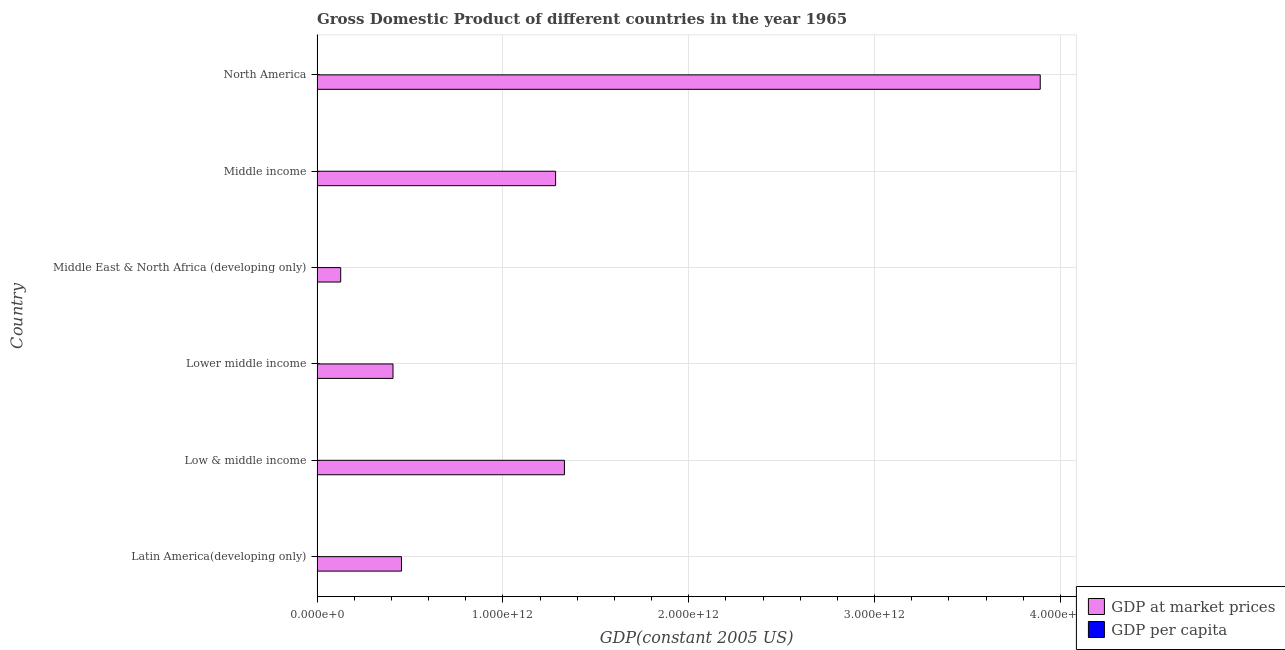How many groups of bars are there?
Provide a short and direct response. 6. Are the number of bars per tick equal to the number of legend labels?
Ensure brevity in your answer.  Yes. How many bars are there on the 4th tick from the bottom?
Ensure brevity in your answer.  2. What is the label of the 2nd group of bars from the top?
Make the answer very short. Middle income. In how many cases, is the number of bars for a given country not equal to the number of legend labels?
Keep it short and to the point. 0. What is the gdp per capita in Latin America(developing only)?
Ensure brevity in your answer.  2209.64. Across all countries, what is the maximum gdp at market prices?
Ensure brevity in your answer.  3.89e+12. Across all countries, what is the minimum gdp per capita?
Provide a short and direct response. 386.81. In which country was the gdp at market prices minimum?
Provide a short and direct response. Middle East & North Africa (developing only). What is the total gdp per capita in the graph?
Provide a succinct answer. 2.31e+04. What is the difference between the gdp at market prices in Low & middle income and that in Lower middle income?
Provide a short and direct response. 9.22e+11. What is the difference between the gdp at market prices in Middle income and the gdp per capita in Middle East & North Africa (developing only)?
Provide a short and direct response. 1.28e+12. What is the average gdp per capita per country?
Ensure brevity in your answer.  3844.58. What is the difference between the gdp per capita and gdp at market prices in Low & middle income?
Ensure brevity in your answer.  -1.33e+12. What is the ratio of the gdp at market prices in Lower middle income to that in Middle East & North Africa (developing only)?
Make the answer very short. 3.21. What is the difference between the highest and the second highest gdp at market prices?
Offer a very short reply. 2.56e+12. What is the difference between the highest and the lowest gdp per capita?
Make the answer very short. 1.78e+04. In how many countries, is the gdp per capita greater than the average gdp per capita taken over all countries?
Give a very brief answer. 1. What does the 2nd bar from the top in Latin America(developing only) represents?
Offer a terse response. GDP at market prices. What does the 2nd bar from the bottom in Lower middle income represents?
Your answer should be very brief. GDP per capita. How many bars are there?
Offer a terse response. 12. How many countries are there in the graph?
Your response must be concise. 6. What is the difference between two consecutive major ticks on the X-axis?
Ensure brevity in your answer.  1.00e+12. Does the graph contain any zero values?
Offer a terse response. No. Does the graph contain grids?
Provide a succinct answer. Yes. Where does the legend appear in the graph?
Your answer should be very brief. Bottom right. What is the title of the graph?
Your response must be concise. Gross Domestic Product of different countries in the year 1965. What is the label or title of the X-axis?
Your answer should be compact. GDP(constant 2005 US). What is the GDP(constant 2005 US) of GDP at market prices in Latin America(developing only)?
Provide a short and direct response. 4.54e+11. What is the GDP(constant 2005 US) in GDP per capita in Latin America(developing only)?
Keep it short and to the point. 2209.64. What is the GDP(constant 2005 US) in GDP at market prices in Low & middle income?
Offer a very short reply. 1.33e+12. What is the GDP(constant 2005 US) of GDP per capita in Low & middle income?
Give a very brief answer. 564.57. What is the GDP(constant 2005 US) in GDP at market prices in Lower middle income?
Your answer should be very brief. 4.09e+11. What is the GDP(constant 2005 US) in GDP per capita in Lower middle income?
Provide a succinct answer. 386.81. What is the GDP(constant 2005 US) of GDP at market prices in Middle East & North Africa (developing only)?
Your response must be concise. 1.27e+11. What is the GDP(constant 2005 US) in GDP per capita in Middle East & North Africa (developing only)?
Ensure brevity in your answer.  1138.46. What is the GDP(constant 2005 US) of GDP at market prices in Middle income?
Provide a succinct answer. 1.28e+12. What is the GDP(constant 2005 US) of GDP per capita in Middle income?
Give a very brief answer. 588.27. What is the GDP(constant 2005 US) of GDP at market prices in North America?
Your answer should be compact. 3.89e+12. What is the GDP(constant 2005 US) in GDP per capita in North America?
Provide a succinct answer. 1.82e+04. Across all countries, what is the maximum GDP(constant 2005 US) of GDP at market prices?
Offer a terse response. 3.89e+12. Across all countries, what is the maximum GDP(constant 2005 US) in GDP per capita?
Make the answer very short. 1.82e+04. Across all countries, what is the minimum GDP(constant 2005 US) in GDP at market prices?
Your response must be concise. 1.27e+11. Across all countries, what is the minimum GDP(constant 2005 US) in GDP per capita?
Offer a terse response. 386.81. What is the total GDP(constant 2005 US) of GDP at market prices in the graph?
Offer a very short reply. 7.50e+12. What is the total GDP(constant 2005 US) of GDP per capita in the graph?
Provide a succinct answer. 2.31e+04. What is the difference between the GDP(constant 2005 US) of GDP at market prices in Latin America(developing only) and that in Low & middle income?
Your answer should be very brief. -8.77e+11. What is the difference between the GDP(constant 2005 US) of GDP per capita in Latin America(developing only) and that in Low & middle income?
Your answer should be very brief. 1645.07. What is the difference between the GDP(constant 2005 US) of GDP at market prices in Latin America(developing only) and that in Lower middle income?
Your answer should be very brief. 4.55e+1. What is the difference between the GDP(constant 2005 US) in GDP per capita in Latin America(developing only) and that in Lower middle income?
Provide a short and direct response. 1822.83. What is the difference between the GDP(constant 2005 US) in GDP at market prices in Latin America(developing only) and that in Middle East & North Africa (developing only)?
Keep it short and to the point. 3.27e+11. What is the difference between the GDP(constant 2005 US) in GDP per capita in Latin America(developing only) and that in Middle East & North Africa (developing only)?
Offer a terse response. 1071.17. What is the difference between the GDP(constant 2005 US) of GDP at market prices in Latin America(developing only) and that in Middle income?
Make the answer very short. -8.29e+11. What is the difference between the GDP(constant 2005 US) in GDP per capita in Latin America(developing only) and that in Middle income?
Your answer should be compact. 1621.37. What is the difference between the GDP(constant 2005 US) of GDP at market prices in Latin America(developing only) and that in North America?
Make the answer very short. -3.44e+12. What is the difference between the GDP(constant 2005 US) of GDP per capita in Latin America(developing only) and that in North America?
Make the answer very short. -1.60e+04. What is the difference between the GDP(constant 2005 US) in GDP at market prices in Low & middle income and that in Lower middle income?
Ensure brevity in your answer.  9.22e+11. What is the difference between the GDP(constant 2005 US) of GDP per capita in Low & middle income and that in Lower middle income?
Your answer should be very brief. 177.76. What is the difference between the GDP(constant 2005 US) of GDP at market prices in Low & middle income and that in Middle East & North Africa (developing only)?
Provide a succinct answer. 1.20e+12. What is the difference between the GDP(constant 2005 US) of GDP per capita in Low & middle income and that in Middle East & North Africa (developing only)?
Offer a very short reply. -573.89. What is the difference between the GDP(constant 2005 US) in GDP at market prices in Low & middle income and that in Middle income?
Give a very brief answer. 4.75e+1. What is the difference between the GDP(constant 2005 US) in GDP per capita in Low & middle income and that in Middle income?
Give a very brief answer. -23.69. What is the difference between the GDP(constant 2005 US) in GDP at market prices in Low & middle income and that in North America?
Offer a very short reply. -2.56e+12. What is the difference between the GDP(constant 2005 US) of GDP per capita in Low & middle income and that in North America?
Provide a succinct answer. -1.76e+04. What is the difference between the GDP(constant 2005 US) in GDP at market prices in Lower middle income and that in Middle East & North Africa (developing only)?
Ensure brevity in your answer.  2.81e+11. What is the difference between the GDP(constant 2005 US) of GDP per capita in Lower middle income and that in Middle East & North Africa (developing only)?
Your response must be concise. -751.65. What is the difference between the GDP(constant 2005 US) in GDP at market prices in Lower middle income and that in Middle income?
Offer a terse response. -8.75e+11. What is the difference between the GDP(constant 2005 US) of GDP per capita in Lower middle income and that in Middle income?
Offer a terse response. -201.46. What is the difference between the GDP(constant 2005 US) of GDP at market prices in Lower middle income and that in North America?
Your response must be concise. -3.48e+12. What is the difference between the GDP(constant 2005 US) of GDP per capita in Lower middle income and that in North America?
Offer a very short reply. -1.78e+04. What is the difference between the GDP(constant 2005 US) in GDP at market prices in Middle East & North Africa (developing only) and that in Middle income?
Provide a short and direct response. -1.16e+12. What is the difference between the GDP(constant 2005 US) of GDP per capita in Middle East & North Africa (developing only) and that in Middle income?
Offer a terse response. 550.2. What is the difference between the GDP(constant 2005 US) in GDP at market prices in Middle East & North Africa (developing only) and that in North America?
Your answer should be very brief. -3.76e+12. What is the difference between the GDP(constant 2005 US) in GDP per capita in Middle East & North Africa (developing only) and that in North America?
Give a very brief answer. -1.70e+04. What is the difference between the GDP(constant 2005 US) in GDP at market prices in Middle income and that in North America?
Your answer should be compact. -2.61e+12. What is the difference between the GDP(constant 2005 US) of GDP per capita in Middle income and that in North America?
Provide a short and direct response. -1.76e+04. What is the difference between the GDP(constant 2005 US) in GDP at market prices in Latin America(developing only) and the GDP(constant 2005 US) in GDP per capita in Low & middle income?
Give a very brief answer. 4.54e+11. What is the difference between the GDP(constant 2005 US) in GDP at market prices in Latin America(developing only) and the GDP(constant 2005 US) in GDP per capita in Lower middle income?
Offer a terse response. 4.54e+11. What is the difference between the GDP(constant 2005 US) of GDP at market prices in Latin America(developing only) and the GDP(constant 2005 US) of GDP per capita in Middle East & North Africa (developing only)?
Offer a terse response. 4.54e+11. What is the difference between the GDP(constant 2005 US) of GDP at market prices in Latin America(developing only) and the GDP(constant 2005 US) of GDP per capita in Middle income?
Offer a very short reply. 4.54e+11. What is the difference between the GDP(constant 2005 US) in GDP at market prices in Latin America(developing only) and the GDP(constant 2005 US) in GDP per capita in North America?
Your answer should be very brief. 4.54e+11. What is the difference between the GDP(constant 2005 US) of GDP at market prices in Low & middle income and the GDP(constant 2005 US) of GDP per capita in Lower middle income?
Your answer should be compact. 1.33e+12. What is the difference between the GDP(constant 2005 US) in GDP at market prices in Low & middle income and the GDP(constant 2005 US) in GDP per capita in Middle East & North Africa (developing only)?
Provide a short and direct response. 1.33e+12. What is the difference between the GDP(constant 2005 US) of GDP at market prices in Low & middle income and the GDP(constant 2005 US) of GDP per capita in Middle income?
Make the answer very short. 1.33e+12. What is the difference between the GDP(constant 2005 US) in GDP at market prices in Low & middle income and the GDP(constant 2005 US) in GDP per capita in North America?
Provide a succinct answer. 1.33e+12. What is the difference between the GDP(constant 2005 US) in GDP at market prices in Lower middle income and the GDP(constant 2005 US) in GDP per capita in Middle East & North Africa (developing only)?
Ensure brevity in your answer.  4.09e+11. What is the difference between the GDP(constant 2005 US) in GDP at market prices in Lower middle income and the GDP(constant 2005 US) in GDP per capita in Middle income?
Your response must be concise. 4.09e+11. What is the difference between the GDP(constant 2005 US) in GDP at market prices in Lower middle income and the GDP(constant 2005 US) in GDP per capita in North America?
Keep it short and to the point. 4.09e+11. What is the difference between the GDP(constant 2005 US) of GDP at market prices in Middle East & North Africa (developing only) and the GDP(constant 2005 US) of GDP per capita in Middle income?
Make the answer very short. 1.27e+11. What is the difference between the GDP(constant 2005 US) in GDP at market prices in Middle East & North Africa (developing only) and the GDP(constant 2005 US) in GDP per capita in North America?
Make the answer very short. 1.27e+11. What is the difference between the GDP(constant 2005 US) of GDP at market prices in Middle income and the GDP(constant 2005 US) of GDP per capita in North America?
Offer a very short reply. 1.28e+12. What is the average GDP(constant 2005 US) in GDP at market prices per country?
Provide a succinct answer. 1.25e+12. What is the average GDP(constant 2005 US) in GDP per capita per country?
Provide a short and direct response. 3844.58. What is the difference between the GDP(constant 2005 US) in GDP at market prices and GDP(constant 2005 US) in GDP per capita in Latin America(developing only)?
Offer a terse response. 4.54e+11. What is the difference between the GDP(constant 2005 US) of GDP at market prices and GDP(constant 2005 US) of GDP per capita in Low & middle income?
Your answer should be compact. 1.33e+12. What is the difference between the GDP(constant 2005 US) of GDP at market prices and GDP(constant 2005 US) of GDP per capita in Lower middle income?
Your response must be concise. 4.09e+11. What is the difference between the GDP(constant 2005 US) in GDP at market prices and GDP(constant 2005 US) in GDP per capita in Middle East & North Africa (developing only)?
Your response must be concise. 1.27e+11. What is the difference between the GDP(constant 2005 US) in GDP at market prices and GDP(constant 2005 US) in GDP per capita in Middle income?
Offer a very short reply. 1.28e+12. What is the difference between the GDP(constant 2005 US) of GDP at market prices and GDP(constant 2005 US) of GDP per capita in North America?
Provide a short and direct response. 3.89e+12. What is the ratio of the GDP(constant 2005 US) in GDP at market prices in Latin America(developing only) to that in Low & middle income?
Make the answer very short. 0.34. What is the ratio of the GDP(constant 2005 US) of GDP per capita in Latin America(developing only) to that in Low & middle income?
Your answer should be very brief. 3.91. What is the ratio of the GDP(constant 2005 US) in GDP at market prices in Latin America(developing only) to that in Lower middle income?
Your answer should be very brief. 1.11. What is the ratio of the GDP(constant 2005 US) in GDP per capita in Latin America(developing only) to that in Lower middle income?
Give a very brief answer. 5.71. What is the ratio of the GDP(constant 2005 US) in GDP at market prices in Latin America(developing only) to that in Middle East & North Africa (developing only)?
Your answer should be compact. 3.57. What is the ratio of the GDP(constant 2005 US) in GDP per capita in Latin America(developing only) to that in Middle East & North Africa (developing only)?
Make the answer very short. 1.94. What is the ratio of the GDP(constant 2005 US) of GDP at market prices in Latin America(developing only) to that in Middle income?
Offer a very short reply. 0.35. What is the ratio of the GDP(constant 2005 US) of GDP per capita in Latin America(developing only) to that in Middle income?
Provide a succinct answer. 3.76. What is the ratio of the GDP(constant 2005 US) in GDP at market prices in Latin America(developing only) to that in North America?
Offer a terse response. 0.12. What is the ratio of the GDP(constant 2005 US) of GDP per capita in Latin America(developing only) to that in North America?
Keep it short and to the point. 0.12. What is the ratio of the GDP(constant 2005 US) in GDP at market prices in Low & middle income to that in Lower middle income?
Your answer should be compact. 3.26. What is the ratio of the GDP(constant 2005 US) in GDP per capita in Low & middle income to that in Lower middle income?
Provide a succinct answer. 1.46. What is the ratio of the GDP(constant 2005 US) of GDP at market prices in Low & middle income to that in Middle East & North Africa (developing only)?
Offer a terse response. 10.46. What is the ratio of the GDP(constant 2005 US) in GDP per capita in Low & middle income to that in Middle East & North Africa (developing only)?
Offer a very short reply. 0.5. What is the ratio of the GDP(constant 2005 US) in GDP at market prices in Low & middle income to that in Middle income?
Make the answer very short. 1.04. What is the ratio of the GDP(constant 2005 US) in GDP per capita in Low & middle income to that in Middle income?
Ensure brevity in your answer.  0.96. What is the ratio of the GDP(constant 2005 US) in GDP at market prices in Low & middle income to that in North America?
Give a very brief answer. 0.34. What is the ratio of the GDP(constant 2005 US) in GDP per capita in Low & middle income to that in North America?
Offer a terse response. 0.03. What is the ratio of the GDP(constant 2005 US) of GDP at market prices in Lower middle income to that in Middle East & North Africa (developing only)?
Offer a terse response. 3.21. What is the ratio of the GDP(constant 2005 US) of GDP per capita in Lower middle income to that in Middle East & North Africa (developing only)?
Your answer should be compact. 0.34. What is the ratio of the GDP(constant 2005 US) of GDP at market prices in Lower middle income to that in Middle income?
Offer a very short reply. 0.32. What is the ratio of the GDP(constant 2005 US) of GDP per capita in Lower middle income to that in Middle income?
Your answer should be compact. 0.66. What is the ratio of the GDP(constant 2005 US) of GDP at market prices in Lower middle income to that in North America?
Offer a terse response. 0.1. What is the ratio of the GDP(constant 2005 US) in GDP per capita in Lower middle income to that in North America?
Provide a short and direct response. 0.02. What is the ratio of the GDP(constant 2005 US) of GDP at market prices in Middle East & North Africa (developing only) to that in Middle income?
Your answer should be very brief. 0.1. What is the ratio of the GDP(constant 2005 US) of GDP per capita in Middle East & North Africa (developing only) to that in Middle income?
Provide a succinct answer. 1.94. What is the ratio of the GDP(constant 2005 US) of GDP at market prices in Middle East & North Africa (developing only) to that in North America?
Your response must be concise. 0.03. What is the ratio of the GDP(constant 2005 US) in GDP per capita in Middle East & North Africa (developing only) to that in North America?
Your answer should be very brief. 0.06. What is the ratio of the GDP(constant 2005 US) of GDP at market prices in Middle income to that in North America?
Your answer should be very brief. 0.33. What is the ratio of the GDP(constant 2005 US) of GDP per capita in Middle income to that in North America?
Give a very brief answer. 0.03. What is the difference between the highest and the second highest GDP(constant 2005 US) in GDP at market prices?
Offer a very short reply. 2.56e+12. What is the difference between the highest and the second highest GDP(constant 2005 US) in GDP per capita?
Provide a short and direct response. 1.60e+04. What is the difference between the highest and the lowest GDP(constant 2005 US) in GDP at market prices?
Offer a very short reply. 3.76e+12. What is the difference between the highest and the lowest GDP(constant 2005 US) in GDP per capita?
Provide a short and direct response. 1.78e+04. 